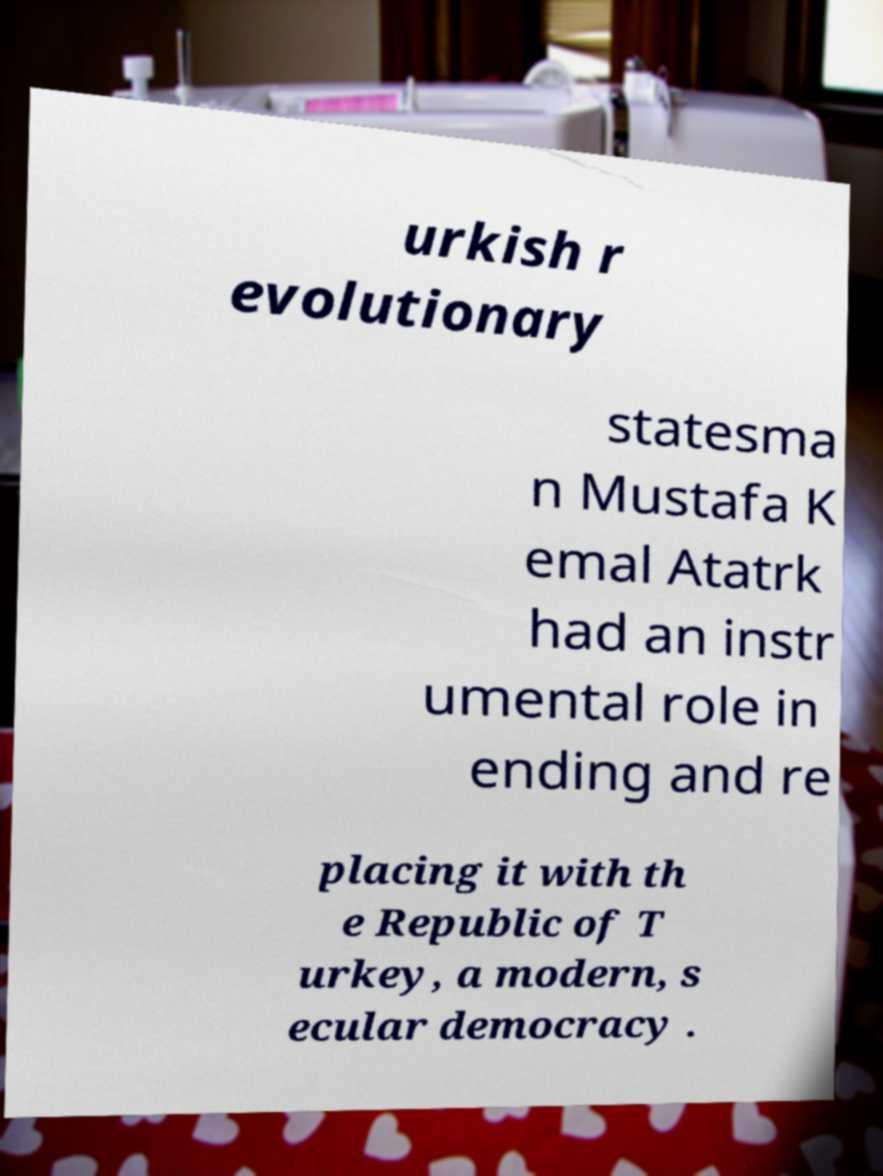I need the written content from this picture converted into text. Can you do that? urkish r evolutionary statesma n Mustafa K emal Atatrk had an instr umental role in ending and re placing it with th e Republic of T urkey, a modern, s ecular democracy . 